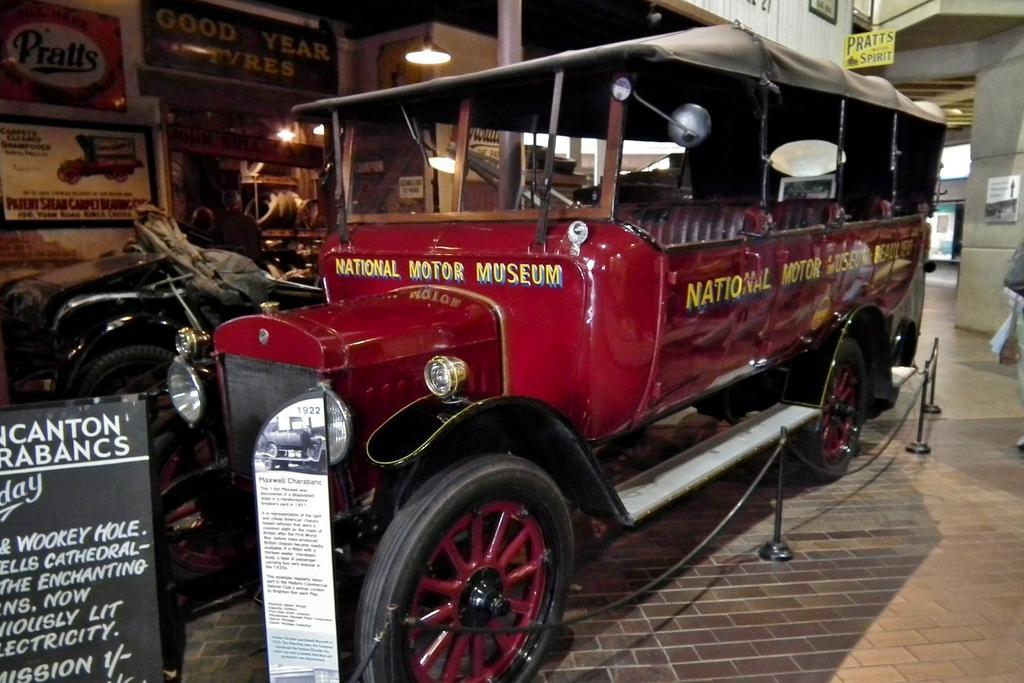Describe this image in one or two sentences. We can see vehicles on the surface,in front of these vehicles we can see boards. Background we can see boards,light and wall. 